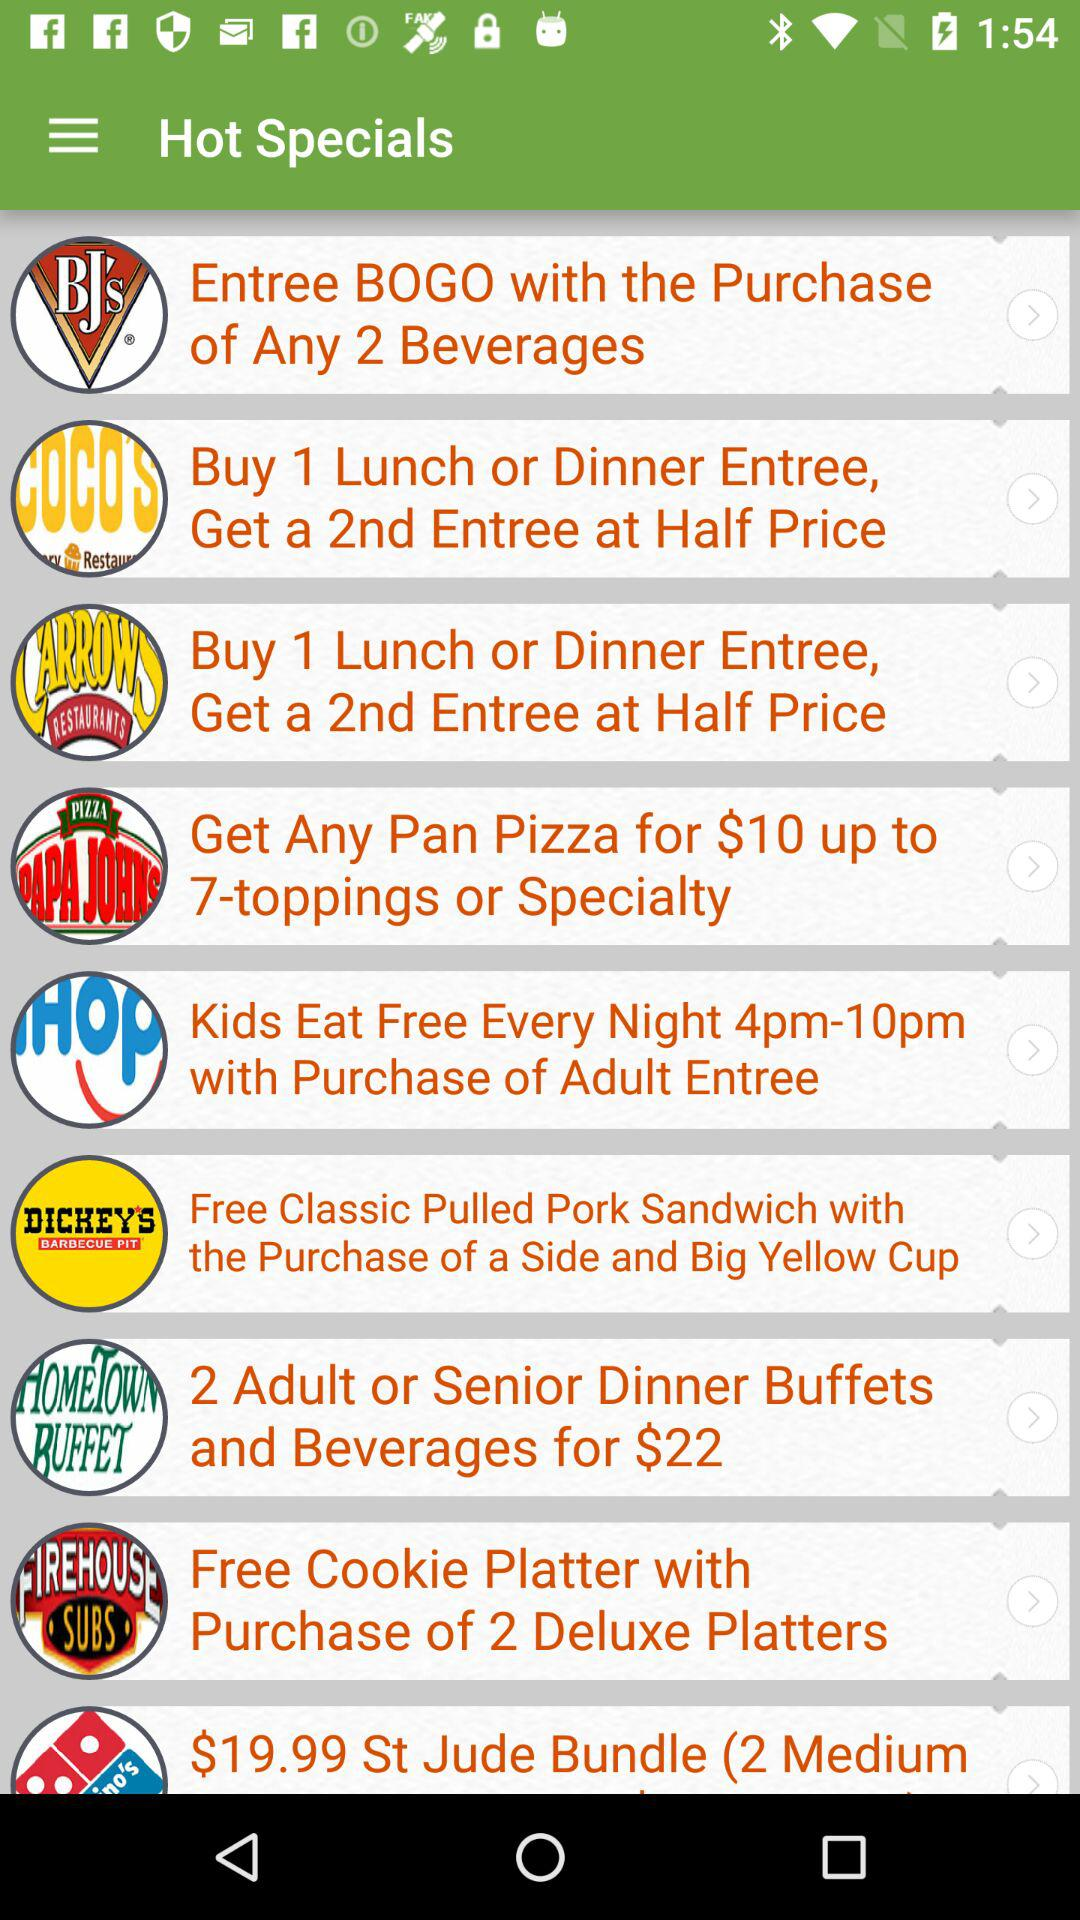What are the hours when kids can eat free with the purchase of an adult entree? The hours when kids can eat free with the purchase of an adult entree are from 4 p.m. to 10 p.m. 